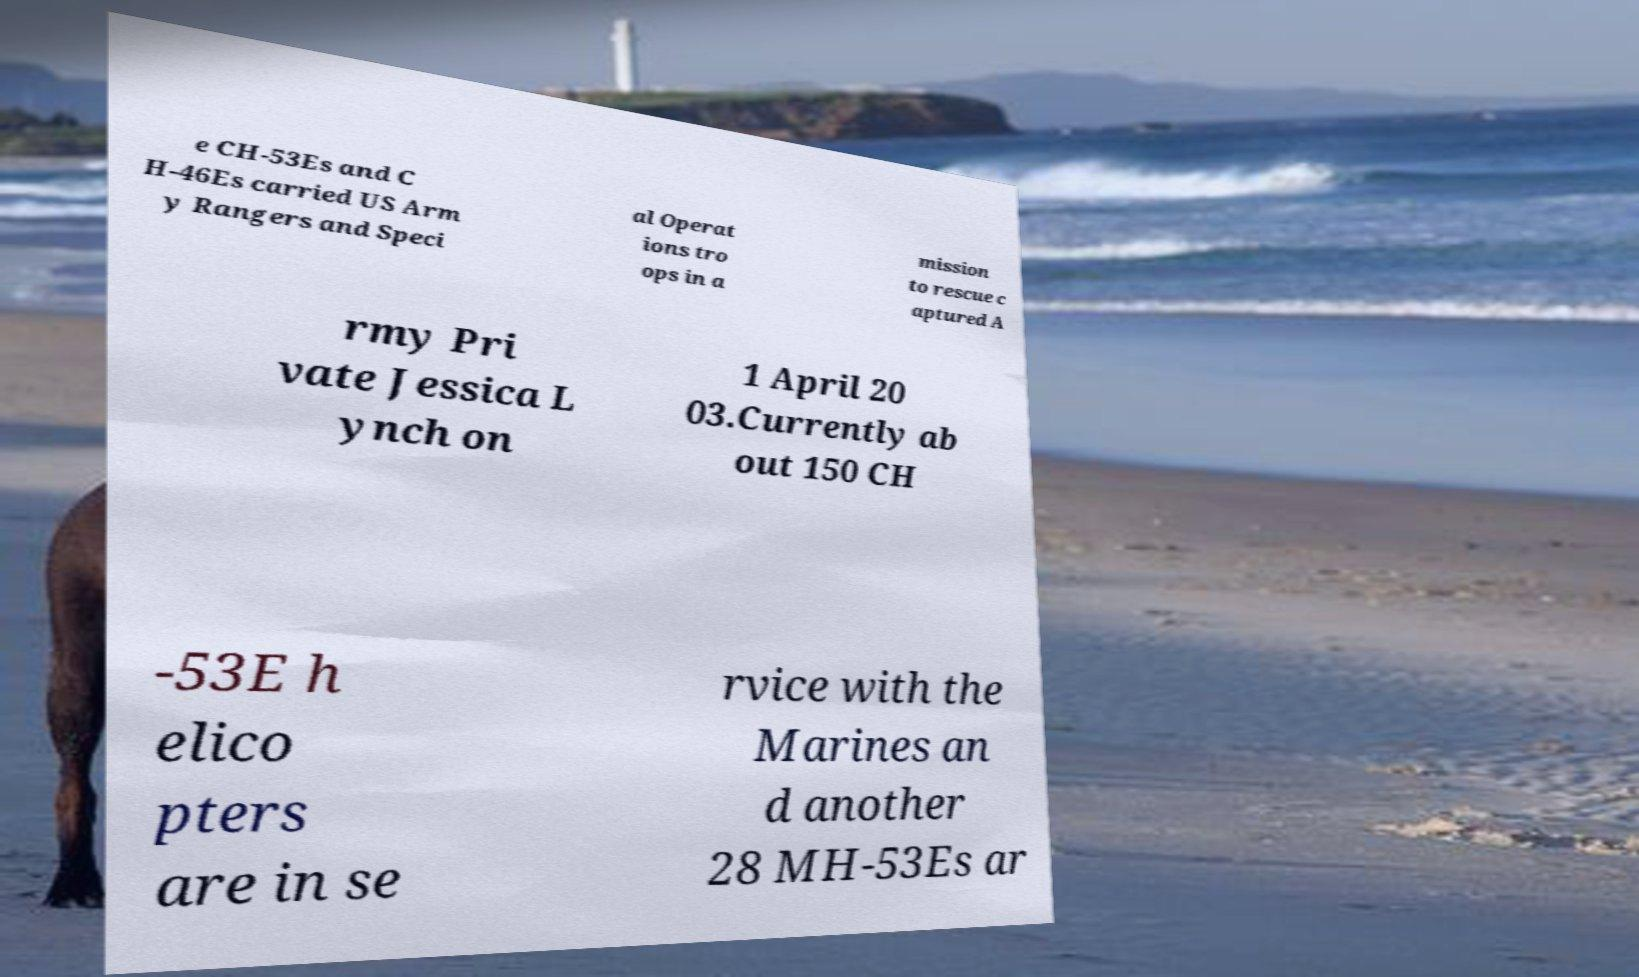Could you assist in decoding the text presented in this image and type it out clearly? e CH-53Es and C H-46Es carried US Arm y Rangers and Speci al Operat ions tro ops in a mission to rescue c aptured A rmy Pri vate Jessica L ynch on 1 April 20 03.Currently ab out 150 CH -53E h elico pters are in se rvice with the Marines an d another 28 MH-53Es ar 